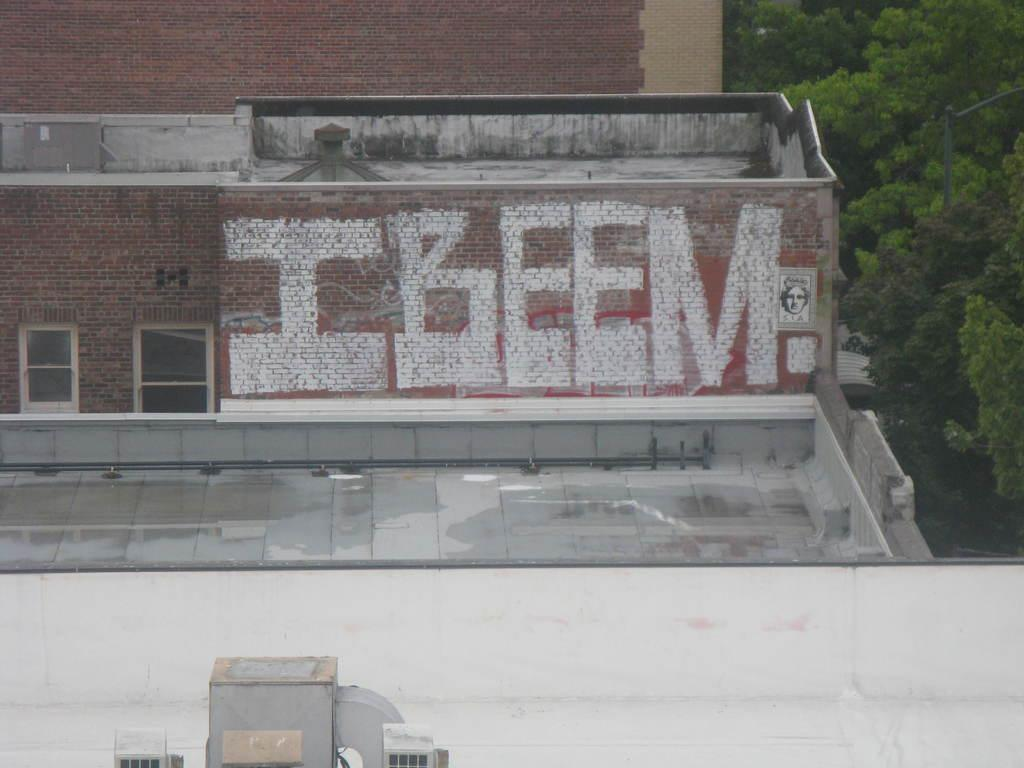What type of openings can be seen in the image? There are windows in the image. What type of structures are visible in the image? There are buildings in the image. What type of outdoor space is present in the image? There is a terrace in the image. What type of cooling system is visible in the image? There are air conditioners in the image. What type of outdoor lighting is present in the image? There is a street light in the image. What type of vegetation is visible in the image? There are trees in the image. What type of acoustics can be heard in the image? There is no sound present in the image, so it is not possible to determine the acoustics. What type of learning is taking place in the image? There is no indication of any learning activity in the image. 